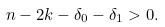Convert formula to latex. <formula><loc_0><loc_0><loc_500><loc_500>n - 2 k - \delta _ { 0 } - \delta _ { 1 } > 0 .</formula> 